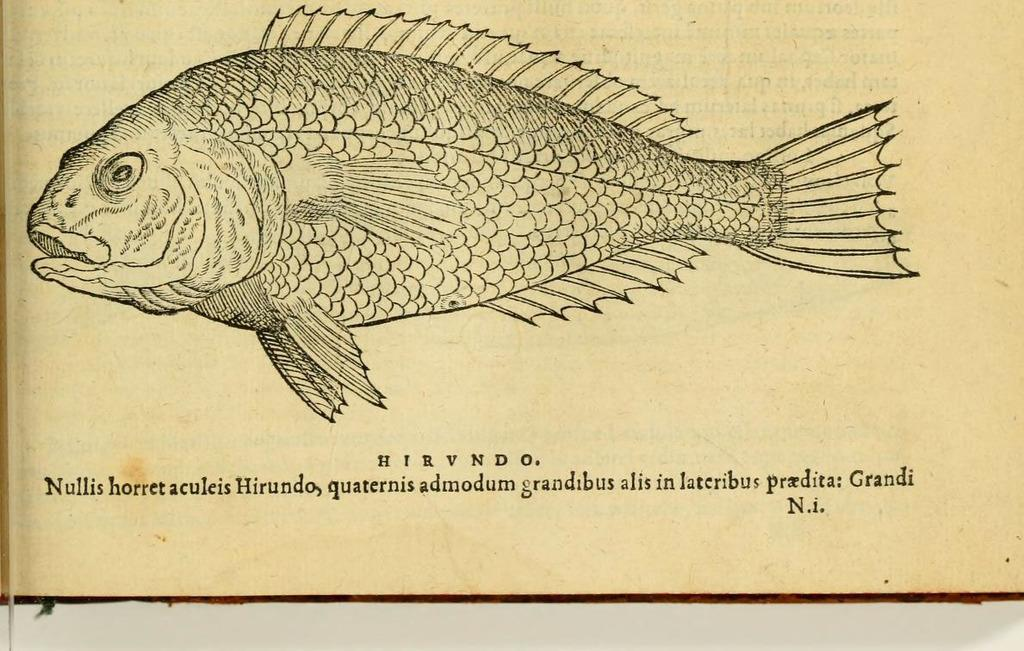What type of animals are present in the image? The image contains fish. Is there any additional information provided about the fish? Yes, there is text at the bottom of the image describing the fish. What is the color of the background in the image? The background of the image is half white. What type of mint can be seen growing in the image? There is no mint present in the image; it contains fish and text about the fish. 